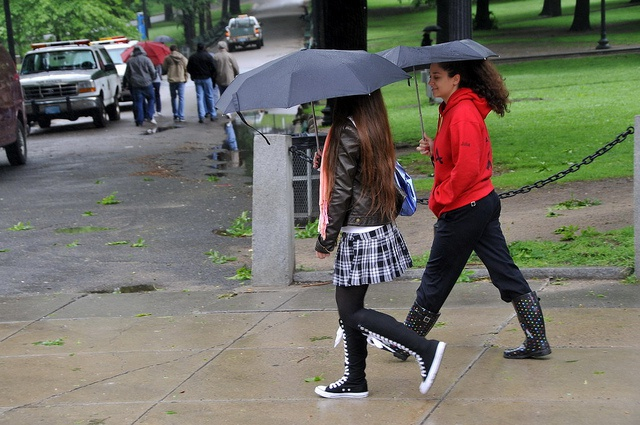Describe the objects in this image and their specific colors. I can see people in darkgreen, black, gray, maroon, and lavender tones, people in darkgreen, black, brown, and maroon tones, umbrella in darkgreen and gray tones, truck in darkgreen, black, purple, darkgray, and lavender tones, and car in darkgreen, black, and gray tones in this image. 